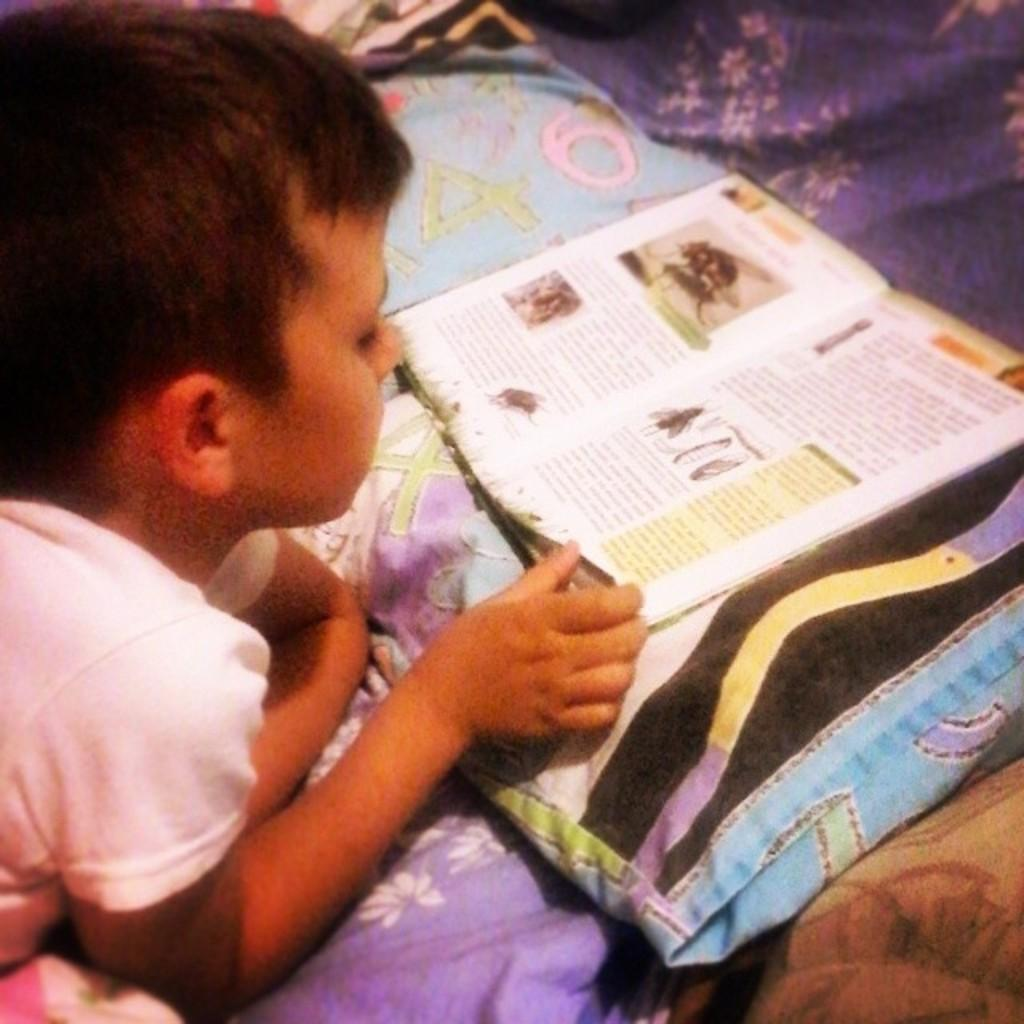Who is the main subject in the image? There is a boy in the image. What is the boy doing in the image? The boy is laying on a bed. What object is in front of the boy? There is a book in front of the boy. Where is the book placed in relation to the boy? The book is on a pillow. What type of engine is visible in the image? There is no engine present in the image. What historical event is the boy studying in the book? The image does not provide information about the content of the book, so it cannot be determined what historical event the boy might be studying. 